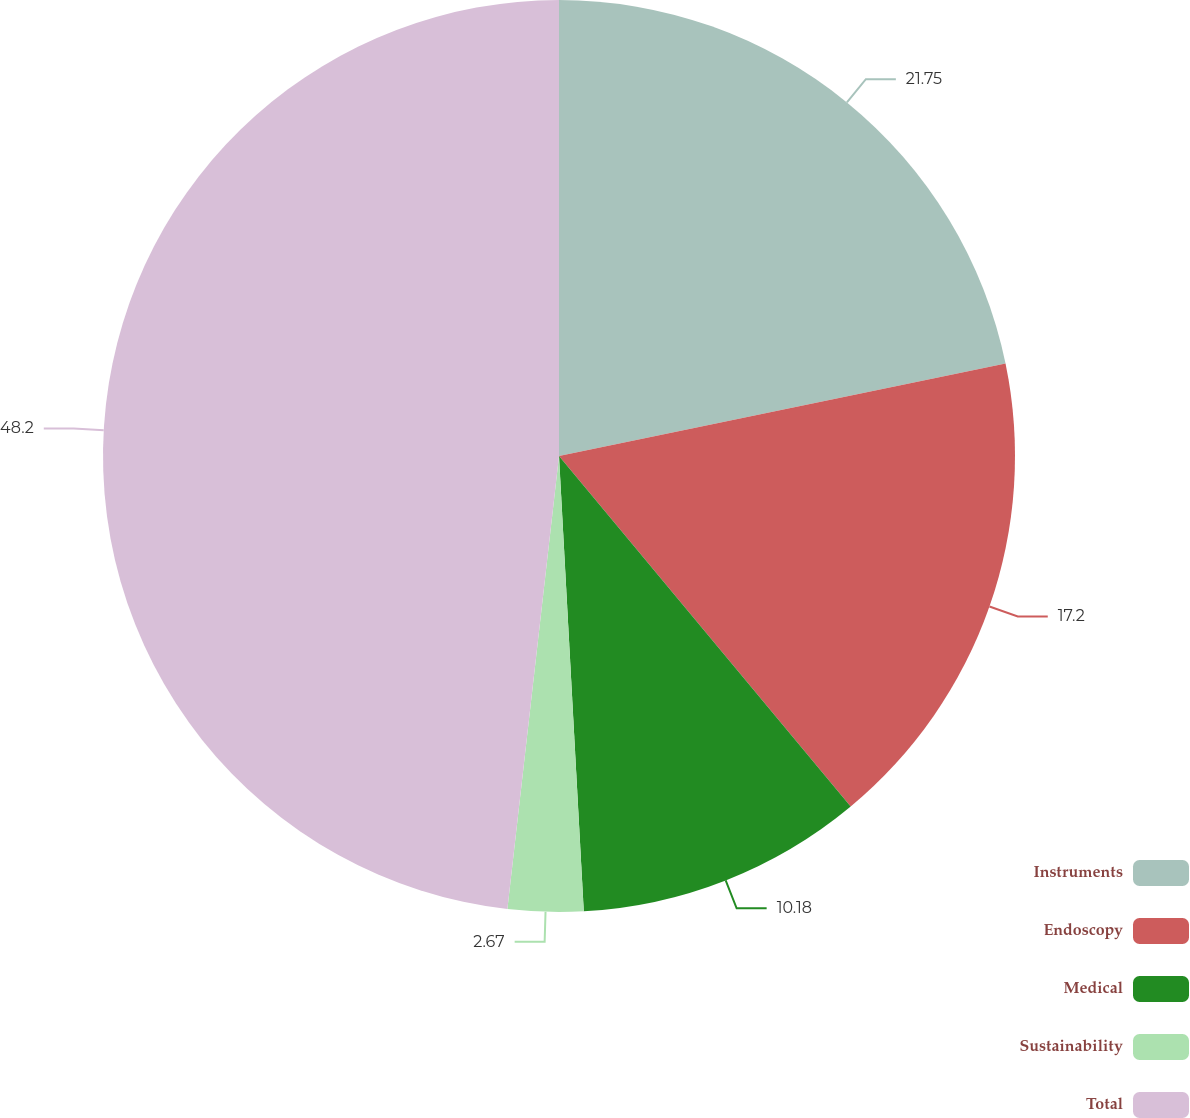Convert chart to OTSL. <chart><loc_0><loc_0><loc_500><loc_500><pie_chart><fcel>Instruments<fcel>Endoscopy<fcel>Medical<fcel>Sustainability<fcel>Total<nl><fcel>21.75%<fcel>17.2%<fcel>10.18%<fcel>2.67%<fcel>48.19%<nl></chart> 